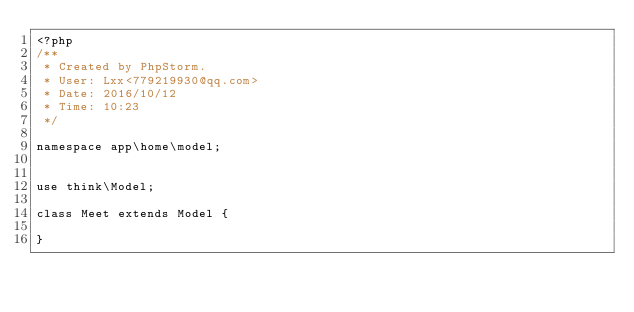<code> <loc_0><loc_0><loc_500><loc_500><_PHP_><?php
/**
 * Created by PhpStorm.
 * User: Lxx<779219930@qq.com>
 * Date: 2016/10/12
 * Time: 10:23
 */

namespace app\home\model;


use think\Model;

class Meet extends Model {

}</code> 